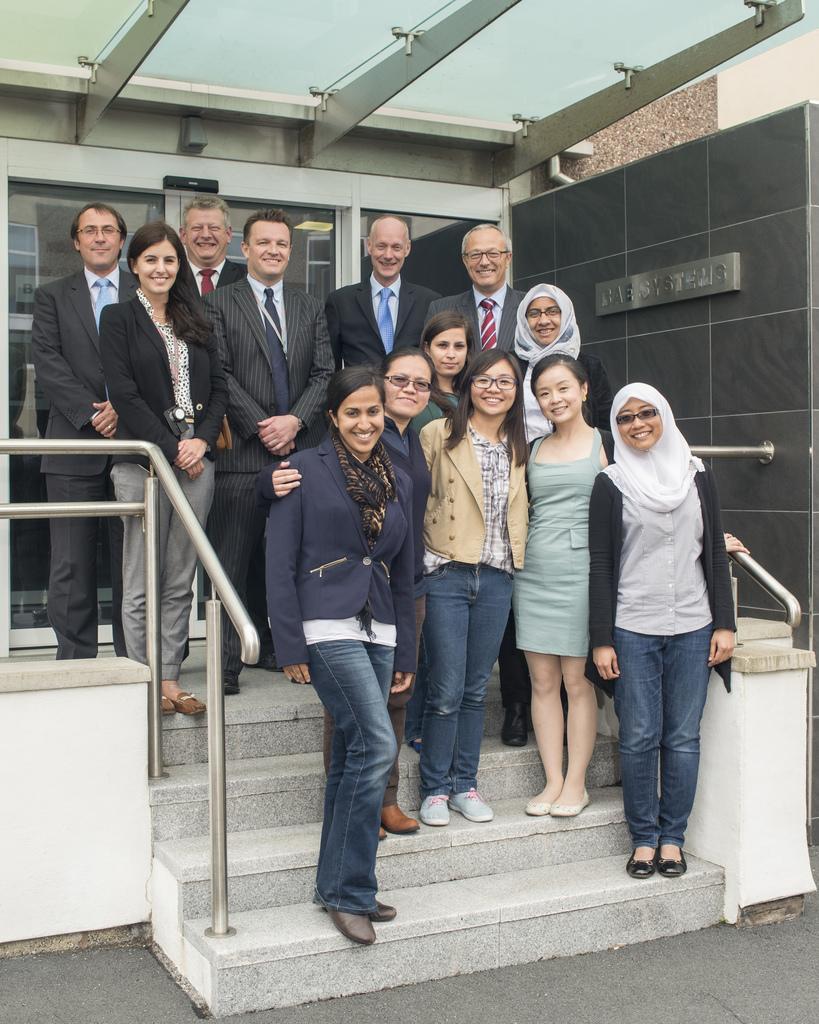Describe this image in one or two sentences. In this image I can see group of people standing. The person in front wearing blue blazer, blue pant. Background I can see a glass door and the wall is in gray color. 